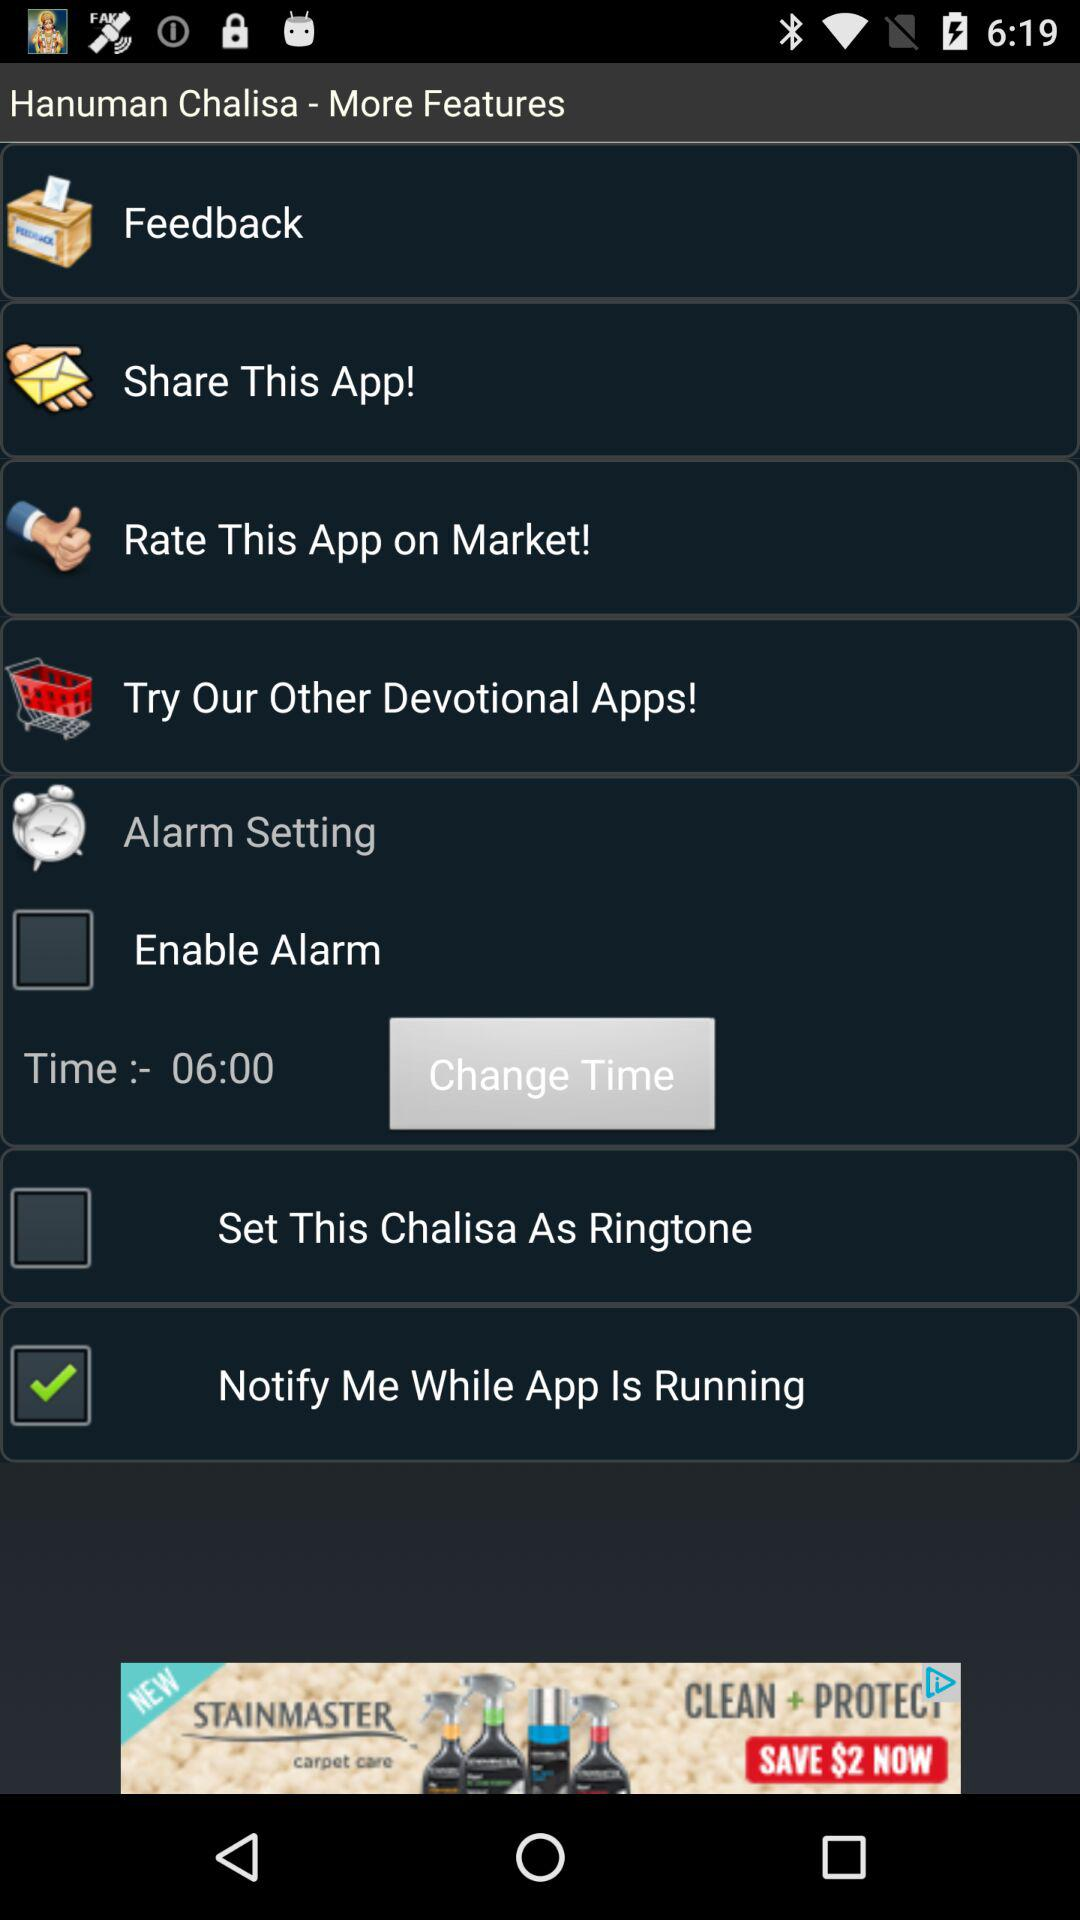At what time will Hanuman Chalisa be played?
When the provided information is insufficient, respond with <no answer>. <no answer> 